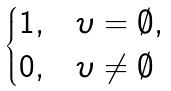Convert formula to latex. <formula><loc_0><loc_0><loc_500><loc_500>\begin{cases} 1 , & { \upsilon } = \emptyset , \\ 0 , & { \upsilon } \neq \emptyset \end{cases}</formula> 